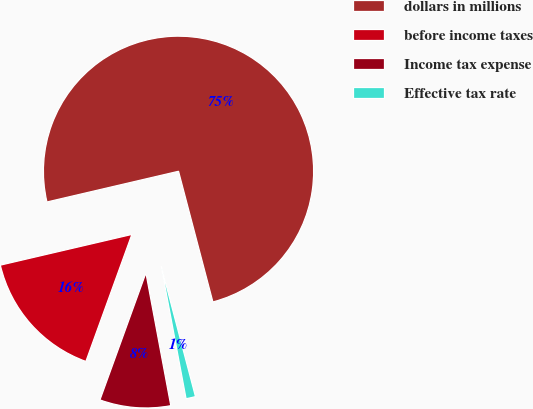Convert chart. <chart><loc_0><loc_0><loc_500><loc_500><pie_chart><fcel>dollars in millions<fcel>before income taxes<fcel>Income tax expense<fcel>Effective tax rate<nl><fcel>74.56%<fcel>15.82%<fcel>8.48%<fcel>1.14%<nl></chart> 